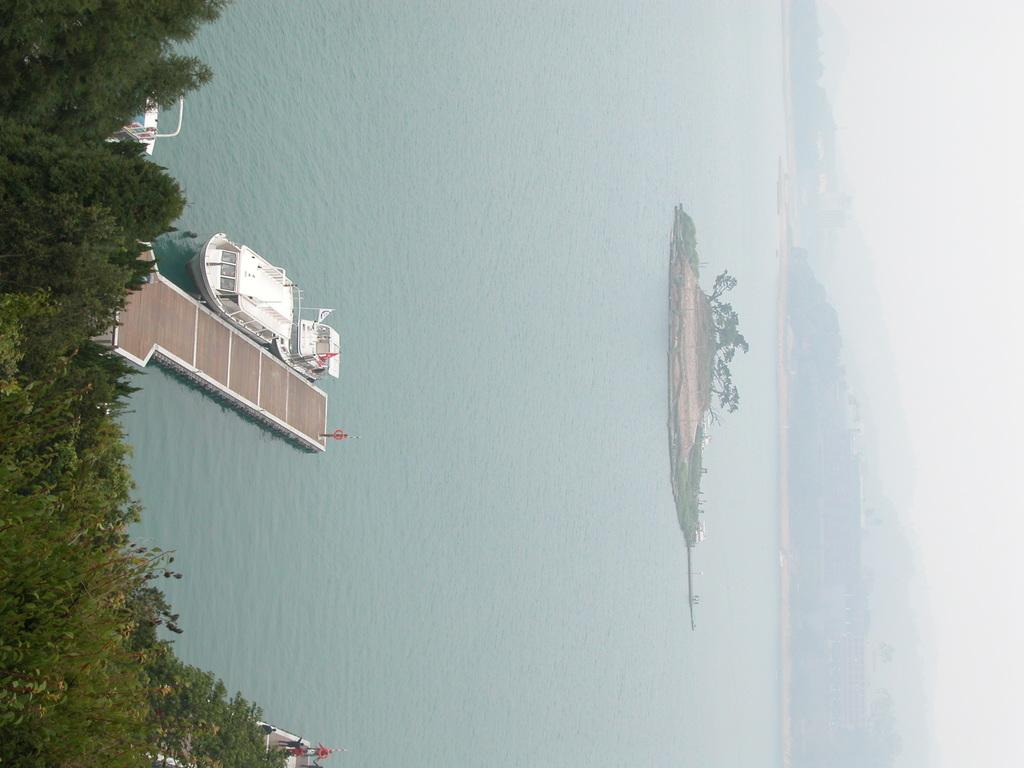What is the main subject in the center of the image? There is a boat in the center of the image. Where is the boat located? The boat is on a river. What else can be seen in the image besides the boat? There is a walkway, a hill on the right side, the sky, and trees on the left side visible in the image. What type of insect can be seen crawling on the page in the image? There is no page or insect present in the image. How many cows are visible on the hill in the image? There are no cows visible in the image; only a boat, river, walkway, hill, sky, and trees are present. 